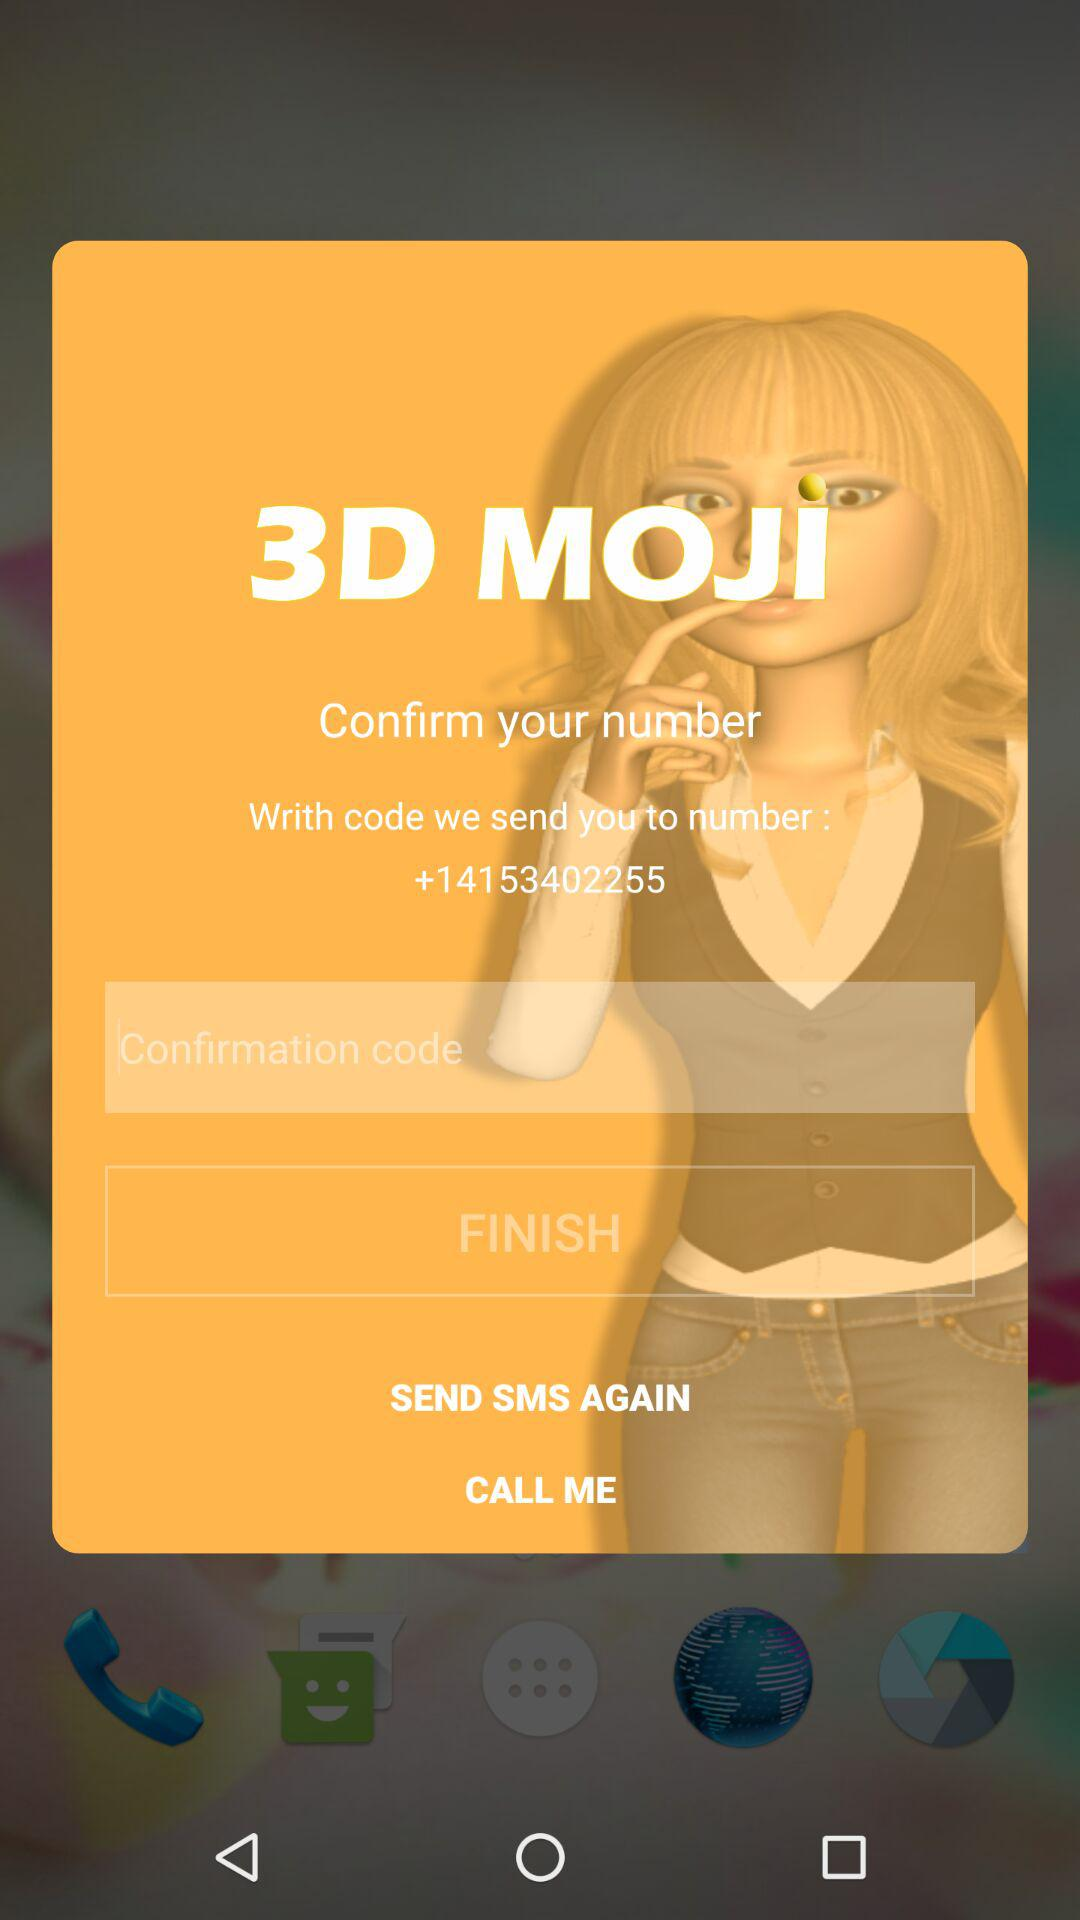What is the mobile number? The mobile number is +14153402255. 